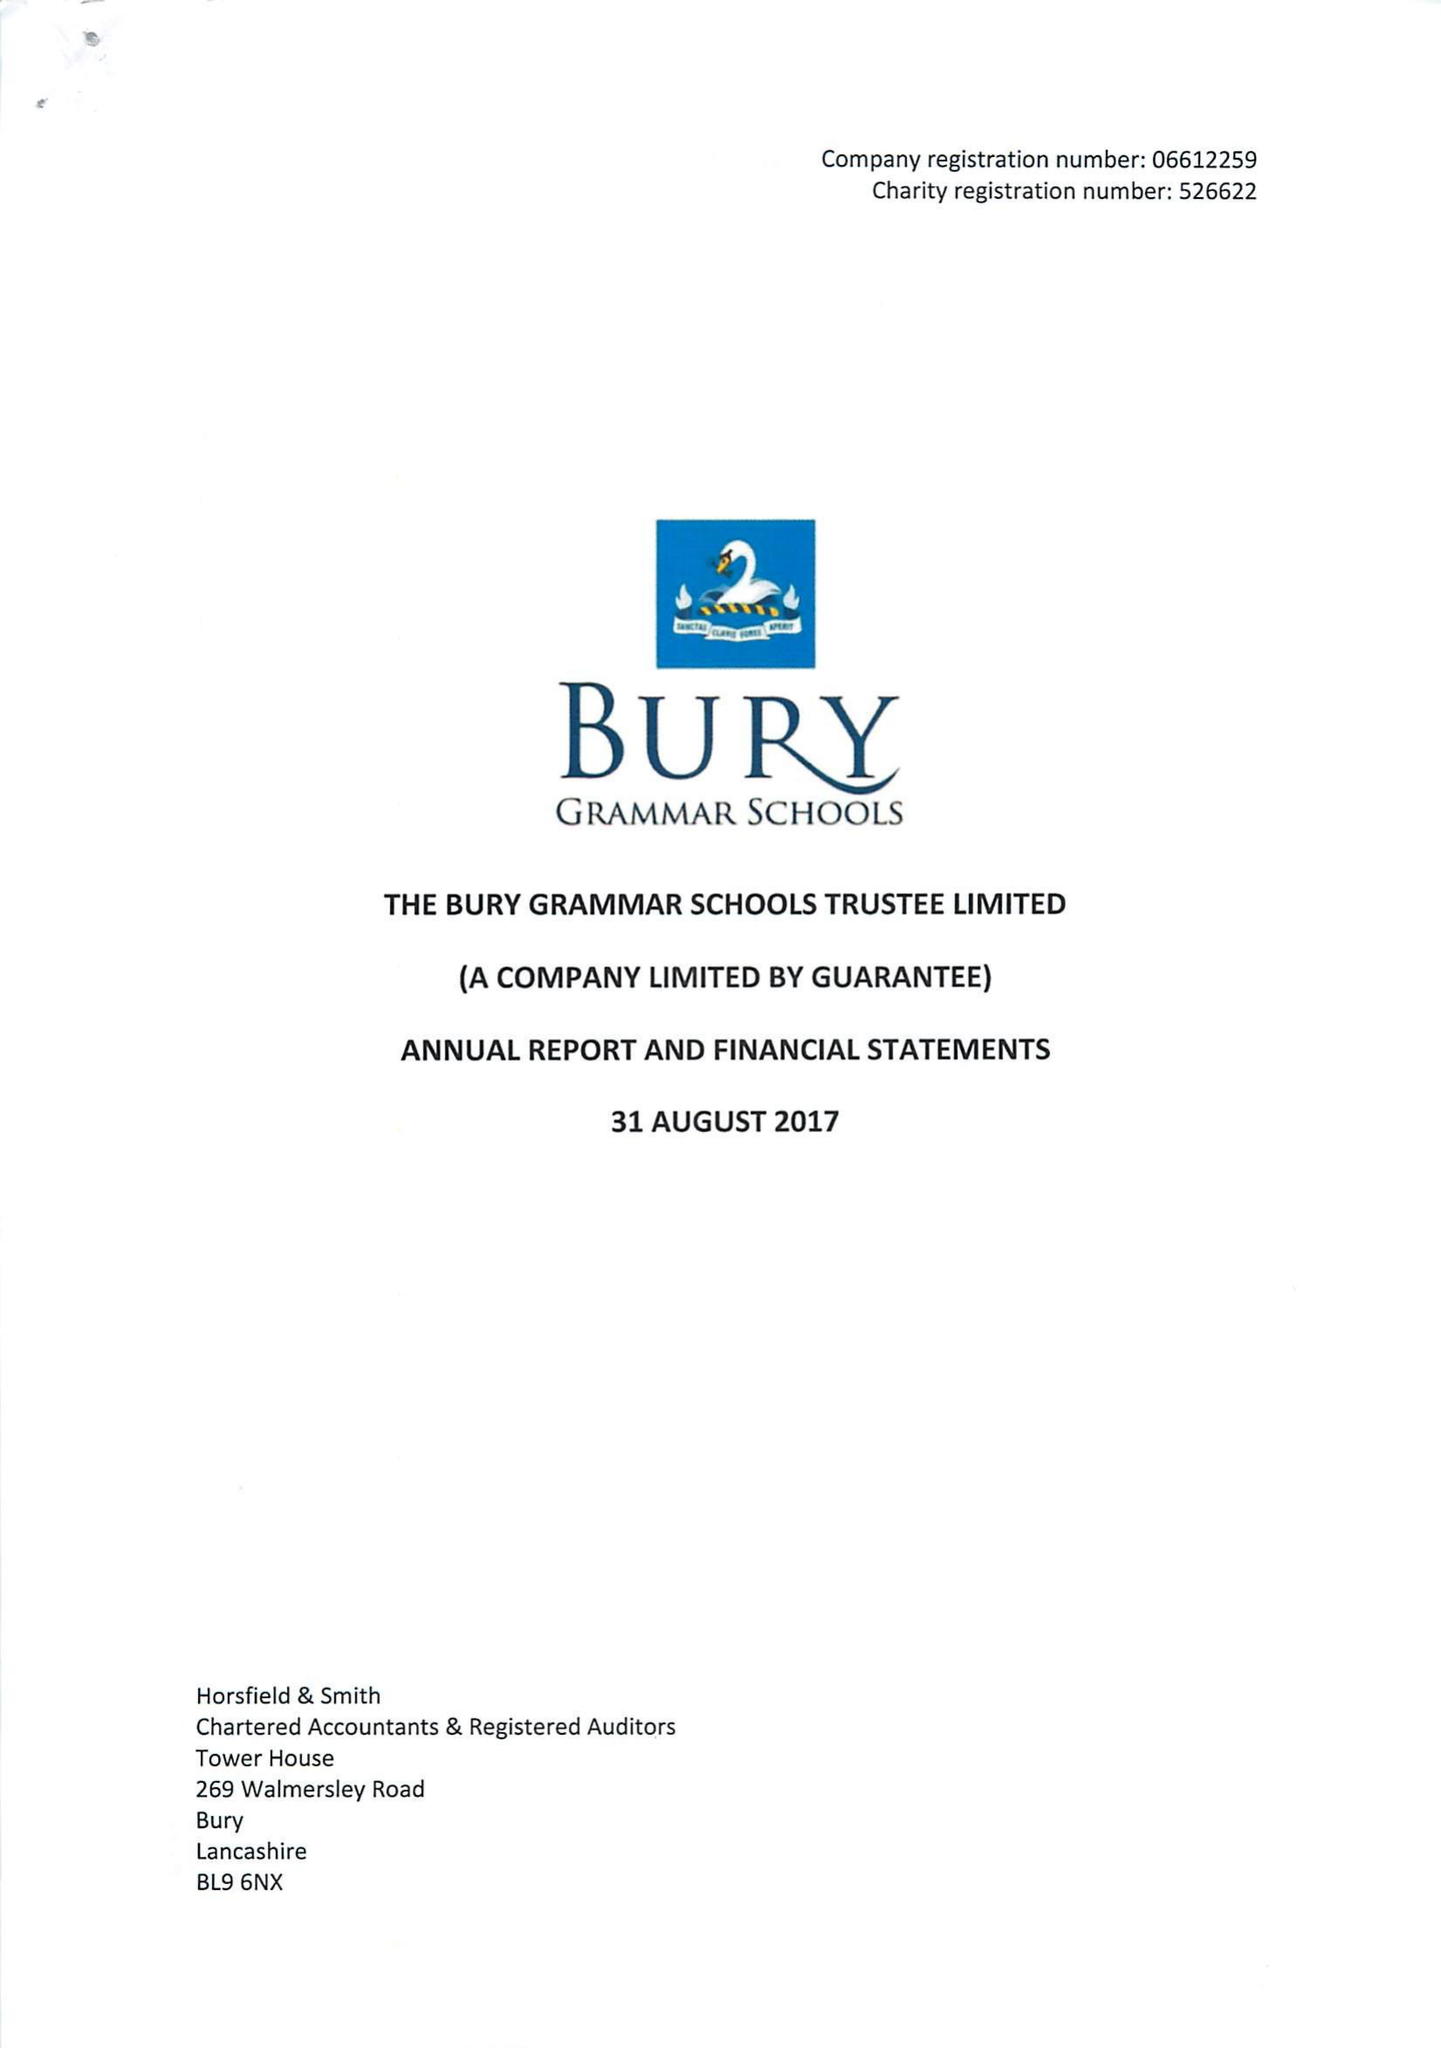What is the value for the income_annually_in_british_pounds?
Answer the question using a single word or phrase. 12619000.00 